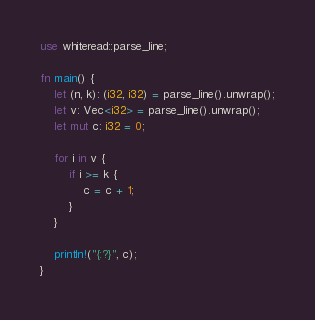<code> <loc_0><loc_0><loc_500><loc_500><_Rust_>use whiteread::parse_line;

fn main() {
    let (n, k): (i32, i32) = parse_line().unwrap();
    let v: Vec<i32> = parse_line().unwrap();
    let mut c: i32 = 0;
    
    for i in v {
        if i >= k {
            c = c + 1;
        }
    }

    println!("{:?}", c);
}
</code> 